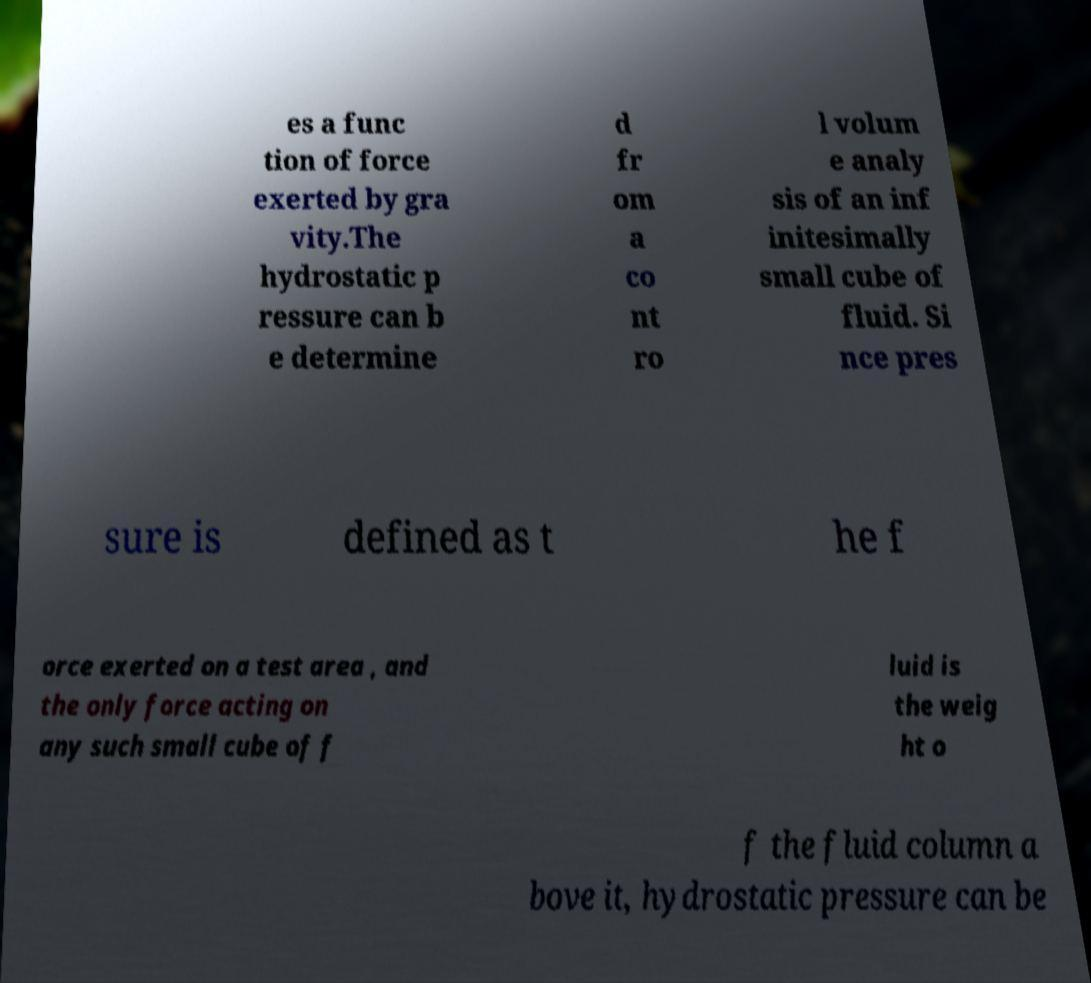I need the written content from this picture converted into text. Can you do that? es a func tion of force exerted by gra vity.The hydrostatic p ressure can b e determine d fr om a co nt ro l volum e analy sis of an inf initesimally small cube of fluid. Si nce pres sure is defined as t he f orce exerted on a test area , and the only force acting on any such small cube of f luid is the weig ht o f the fluid column a bove it, hydrostatic pressure can be 